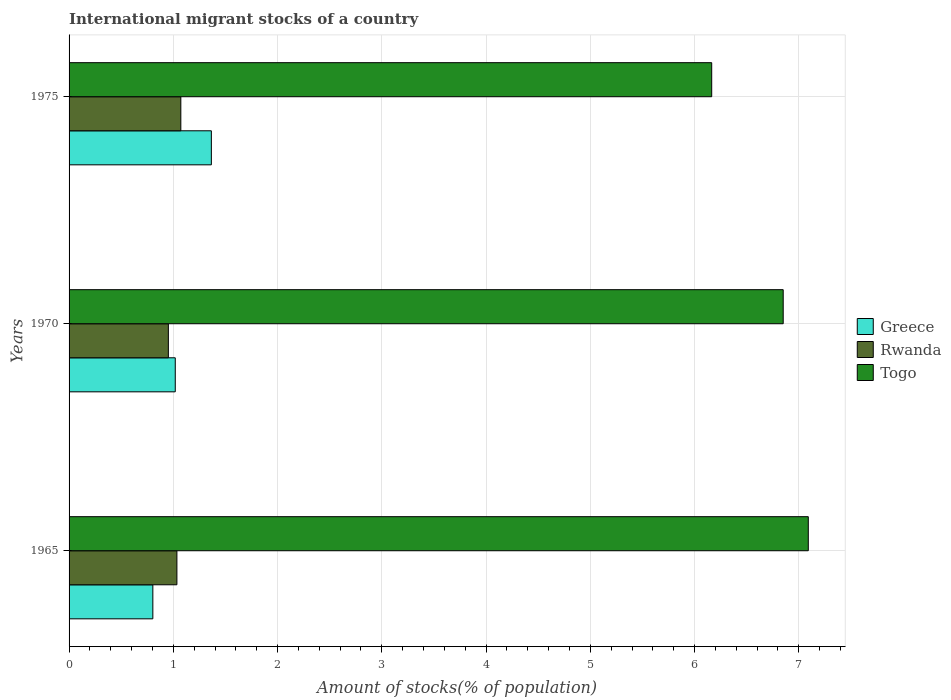How many different coloured bars are there?
Provide a succinct answer. 3. How many bars are there on the 1st tick from the top?
Keep it short and to the point. 3. How many bars are there on the 2nd tick from the bottom?
Offer a very short reply. 3. What is the label of the 1st group of bars from the top?
Offer a very short reply. 1975. What is the amount of stocks in in Togo in 1975?
Your answer should be compact. 6.16. Across all years, what is the maximum amount of stocks in in Rwanda?
Your answer should be very brief. 1.07. Across all years, what is the minimum amount of stocks in in Greece?
Provide a short and direct response. 0.8. In which year was the amount of stocks in in Togo maximum?
Provide a succinct answer. 1965. In which year was the amount of stocks in in Togo minimum?
Your response must be concise. 1975. What is the total amount of stocks in in Rwanda in the graph?
Make the answer very short. 3.06. What is the difference between the amount of stocks in in Togo in 1970 and that in 1975?
Your answer should be very brief. 0.69. What is the difference between the amount of stocks in in Togo in 1970 and the amount of stocks in in Greece in 1965?
Provide a succinct answer. 6.05. What is the average amount of stocks in in Rwanda per year?
Provide a short and direct response. 1.02. In the year 1975, what is the difference between the amount of stocks in in Greece and amount of stocks in in Rwanda?
Offer a very short reply. 0.29. In how many years, is the amount of stocks in in Togo greater than 4.6 %?
Provide a succinct answer. 3. What is the ratio of the amount of stocks in in Togo in 1965 to that in 1975?
Provide a succinct answer. 1.15. What is the difference between the highest and the second highest amount of stocks in in Greece?
Offer a very short reply. 0.35. What is the difference between the highest and the lowest amount of stocks in in Greece?
Offer a very short reply. 0.56. In how many years, is the amount of stocks in in Greece greater than the average amount of stocks in in Greece taken over all years?
Your response must be concise. 1. What does the 2nd bar from the top in 1965 represents?
Your response must be concise. Rwanda. How many bars are there?
Keep it short and to the point. 9. Are the values on the major ticks of X-axis written in scientific E-notation?
Offer a terse response. No. Does the graph contain any zero values?
Your response must be concise. No. Where does the legend appear in the graph?
Keep it short and to the point. Center right. What is the title of the graph?
Your answer should be very brief. International migrant stocks of a country. What is the label or title of the X-axis?
Your response must be concise. Amount of stocks(% of population). What is the label or title of the Y-axis?
Give a very brief answer. Years. What is the Amount of stocks(% of population) in Greece in 1965?
Your response must be concise. 0.8. What is the Amount of stocks(% of population) in Rwanda in 1965?
Provide a succinct answer. 1.03. What is the Amount of stocks(% of population) of Togo in 1965?
Provide a short and direct response. 7.09. What is the Amount of stocks(% of population) in Greece in 1970?
Make the answer very short. 1.02. What is the Amount of stocks(% of population) in Rwanda in 1970?
Give a very brief answer. 0.95. What is the Amount of stocks(% of population) in Togo in 1970?
Keep it short and to the point. 6.85. What is the Amount of stocks(% of population) in Greece in 1975?
Your response must be concise. 1.36. What is the Amount of stocks(% of population) of Rwanda in 1975?
Your answer should be compact. 1.07. What is the Amount of stocks(% of population) in Togo in 1975?
Provide a succinct answer. 6.16. Across all years, what is the maximum Amount of stocks(% of population) in Greece?
Your answer should be compact. 1.36. Across all years, what is the maximum Amount of stocks(% of population) of Rwanda?
Your answer should be very brief. 1.07. Across all years, what is the maximum Amount of stocks(% of population) of Togo?
Keep it short and to the point. 7.09. Across all years, what is the minimum Amount of stocks(% of population) of Greece?
Make the answer very short. 0.8. Across all years, what is the minimum Amount of stocks(% of population) of Rwanda?
Offer a terse response. 0.95. Across all years, what is the minimum Amount of stocks(% of population) of Togo?
Provide a short and direct response. 6.16. What is the total Amount of stocks(% of population) in Greece in the graph?
Offer a terse response. 3.19. What is the total Amount of stocks(% of population) in Rwanda in the graph?
Provide a short and direct response. 3.06. What is the total Amount of stocks(% of population) in Togo in the graph?
Provide a short and direct response. 20.11. What is the difference between the Amount of stocks(% of population) of Greece in 1965 and that in 1970?
Keep it short and to the point. -0.22. What is the difference between the Amount of stocks(% of population) of Rwanda in 1965 and that in 1970?
Offer a very short reply. 0.08. What is the difference between the Amount of stocks(% of population) of Togo in 1965 and that in 1970?
Offer a terse response. 0.24. What is the difference between the Amount of stocks(% of population) in Greece in 1965 and that in 1975?
Your response must be concise. -0.56. What is the difference between the Amount of stocks(% of population) of Rwanda in 1965 and that in 1975?
Offer a very short reply. -0.04. What is the difference between the Amount of stocks(% of population) of Togo in 1965 and that in 1975?
Give a very brief answer. 0.93. What is the difference between the Amount of stocks(% of population) of Greece in 1970 and that in 1975?
Offer a terse response. -0.35. What is the difference between the Amount of stocks(% of population) in Rwanda in 1970 and that in 1975?
Your answer should be very brief. -0.12. What is the difference between the Amount of stocks(% of population) of Togo in 1970 and that in 1975?
Keep it short and to the point. 0.69. What is the difference between the Amount of stocks(% of population) in Greece in 1965 and the Amount of stocks(% of population) in Rwanda in 1970?
Make the answer very short. -0.15. What is the difference between the Amount of stocks(% of population) in Greece in 1965 and the Amount of stocks(% of population) in Togo in 1970?
Offer a terse response. -6.05. What is the difference between the Amount of stocks(% of population) in Rwanda in 1965 and the Amount of stocks(% of population) in Togo in 1970?
Provide a succinct answer. -5.82. What is the difference between the Amount of stocks(% of population) of Greece in 1965 and the Amount of stocks(% of population) of Rwanda in 1975?
Your answer should be very brief. -0.27. What is the difference between the Amount of stocks(% of population) in Greece in 1965 and the Amount of stocks(% of population) in Togo in 1975?
Your answer should be compact. -5.36. What is the difference between the Amount of stocks(% of population) in Rwanda in 1965 and the Amount of stocks(% of population) in Togo in 1975?
Offer a terse response. -5.13. What is the difference between the Amount of stocks(% of population) of Greece in 1970 and the Amount of stocks(% of population) of Rwanda in 1975?
Your response must be concise. -0.05. What is the difference between the Amount of stocks(% of population) in Greece in 1970 and the Amount of stocks(% of population) in Togo in 1975?
Ensure brevity in your answer.  -5.15. What is the difference between the Amount of stocks(% of population) of Rwanda in 1970 and the Amount of stocks(% of population) of Togo in 1975?
Ensure brevity in your answer.  -5.21. What is the average Amount of stocks(% of population) of Greece per year?
Your response must be concise. 1.06. What is the average Amount of stocks(% of population) in Rwanda per year?
Your answer should be compact. 1.02. What is the average Amount of stocks(% of population) in Togo per year?
Keep it short and to the point. 6.7. In the year 1965, what is the difference between the Amount of stocks(% of population) of Greece and Amount of stocks(% of population) of Rwanda?
Provide a short and direct response. -0.23. In the year 1965, what is the difference between the Amount of stocks(% of population) of Greece and Amount of stocks(% of population) of Togo?
Make the answer very short. -6.29. In the year 1965, what is the difference between the Amount of stocks(% of population) in Rwanda and Amount of stocks(% of population) in Togo?
Your answer should be very brief. -6.06. In the year 1970, what is the difference between the Amount of stocks(% of population) of Greece and Amount of stocks(% of population) of Rwanda?
Keep it short and to the point. 0.07. In the year 1970, what is the difference between the Amount of stocks(% of population) of Greece and Amount of stocks(% of population) of Togo?
Your answer should be very brief. -5.83. In the year 1970, what is the difference between the Amount of stocks(% of population) of Rwanda and Amount of stocks(% of population) of Togo?
Ensure brevity in your answer.  -5.9. In the year 1975, what is the difference between the Amount of stocks(% of population) of Greece and Amount of stocks(% of population) of Rwanda?
Keep it short and to the point. 0.29. In the year 1975, what is the difference between the Amount of stocks(% of population) of Greece and Amount of stocks(% of population) of Togo?
Provide a short and direct response. -4.8. In the year 1975, what is the difference between the Amount of stocks(% of population) of Rwanda and Amount of stocks(% of population) of Togo?
Ensure brevity in your answer.  -5.09. What is the ratio of the Amount of stocks(% of population) of Greece in 1965 to that in 1970?
Provide a succinct answer. 0.79. What is the ratio of the Amount of stocks(% of population) in Rwanda in 1965 to that in 1970?
Provide a short and direct response. 1.09. What is the ratio of the Amount of stocks(% of population) of Togo in 1965 to that in 1970?
Make the answer very short. 1.04. What is the ratio of the Amount of stocks(% of population) of Greece in 1965 to that in 1975?
Ensure brevity in your answer.  0.59. What is the ratio of the Amount of stocks(% of population) in Rwanda in 1965 to that in 1975?
Provide a succinct answer. 0.96. What is the ratio of the Amount of stocks(% of population) in Togo in 1965 to that in 1975?
Ensure brevity in your answer.  1.15. What is the ratio of the Amount of stocks(% of population) in Greece in 1970 to that in 1975?
Provide a succinct answer. 0.75. What is the ratio of the Amount of stocks(% of population) of Rwanda in 1970 to that in 1975?
Keep it short and to the point. 0.89. What is the ratio of the Amount of stocks(% of population) in Togo in 1970 to that in 1975?
Offer a very short reply. 1.11. What is the difference between the highest and the second highest Amount of stocks(% of population) of Greece?
Make the answer very short. 0.35. What is the difference between the highest and the second highest Amount of stocks(% of population) in Rwanda?
Keep it short and to the point. 0.04. What is the difference between the highest and the second highest Amount of stocks(% of population) in Togo?
Keep it short and to the point. 0.24. What is the difference between the highest and the lowest Amount of stocks(% of population) of Greece?
Offer a terse response. 0.56. What is the difference between the highest and the lowest Amount of stocks(% of population) in Rwanda?
Your response must be concise. 0.12. What is the difference between the highest and the lowest Amount of stocks(% of population) of Togo?
Offer a terse response. 0.93. 